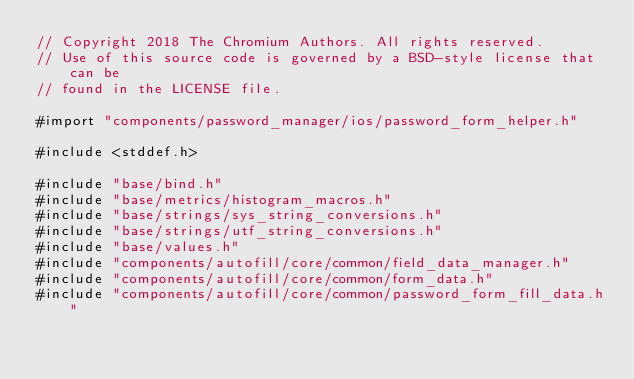Convert code to text. <code><loc_0><loc_0><loc_500><loc_500><_ObjectiveC_>// Copyright 2018 The Chromium Authors. All rights reserved.
// Use of this source code is governed by a BSD-style license that can be
// found in the LICENSE file.

#import "components/password_manager/ios/password_form_helper.h"

#include <stddef.h>

#include "base/bind.h"
#include "base/metrics/histogram_macros.h"
#include "base/strings/sys_string_conversions.h"
#include "base/strings/utf_string_conversions.h"
#include "base/values.h"
#include "components/autofill/core/common/field_data_manager.h"
#include "components/autofill/core/common/form_data.h"
#include "components/autofill/core/common/password_form_fill_data.h"</code> 